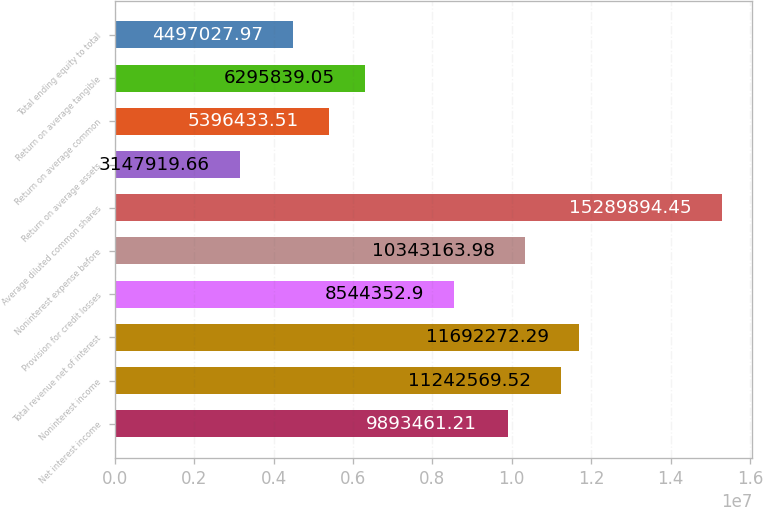Convert chart. <chart><loc_0><loc_0><loc_500><loc_500><bar_chart><fcel>Net interest income<fcel>Noninterest income<fcel>Total revenue net of interest<fcel>Provision for credit losses<fcel>Noninterest expense before<fcel>Average diluted common shares<fcel>Return on average assets<fcel>Return on average common<fcel>Return on average tangible<fcel>Total ending equity to total<nl><fcel>9.89346e+06<fcel>1.12426e+07<fcel>1.16923e+07<fcel>8.54435e+06<fcel>1.03432e+07<fcel>1.52899e+07<fcel>3.14792e+06<fcel>5.39643e+06<fcel>6.29584e+06<fcel>4.49703e+06<nl></chart> 